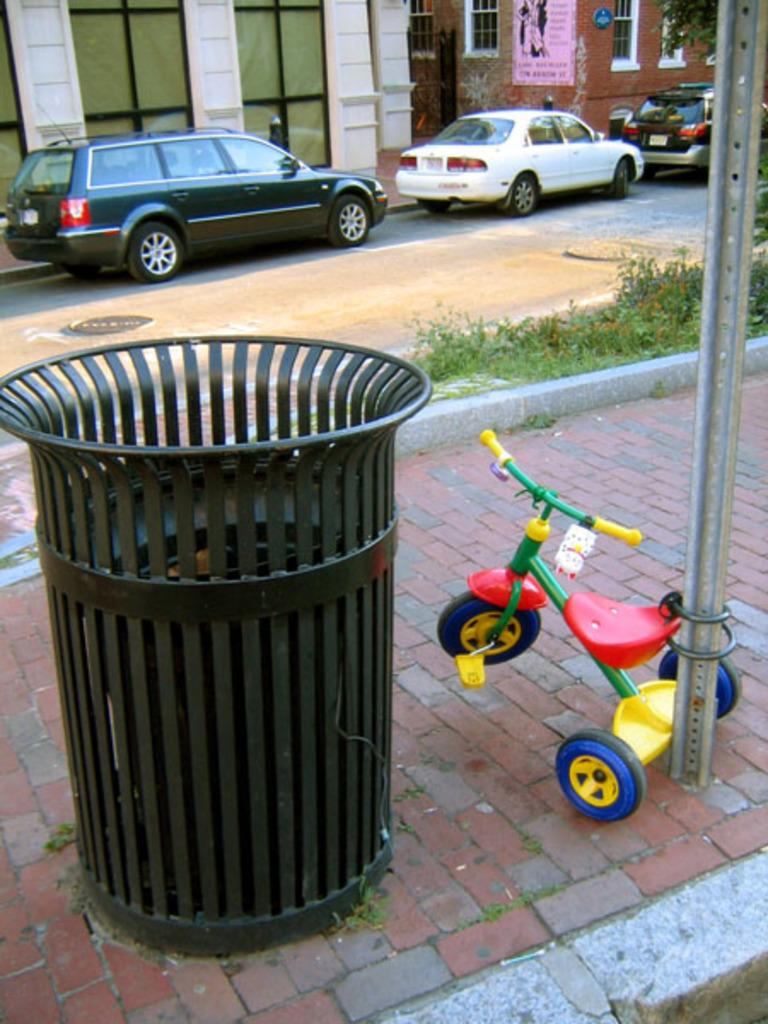What object is present in the image for waste disposal? There is a dustbin in the image. What type of vehicle for children can be seen in the image? There is a baby bicycle tied to a pole in the image. What can be seen moving on the road in the image? There are vehicles on the road in the image. What type of structures are visible in the distance in the image? There are buildings in the background of the image. What type of ice can be seen melting on the baby bicycle in the image? There is no ice present on the baby bicycle in the image. What country is depicted in the background of the image? The image does not depict a specific country; it only shows buildings in the background. 